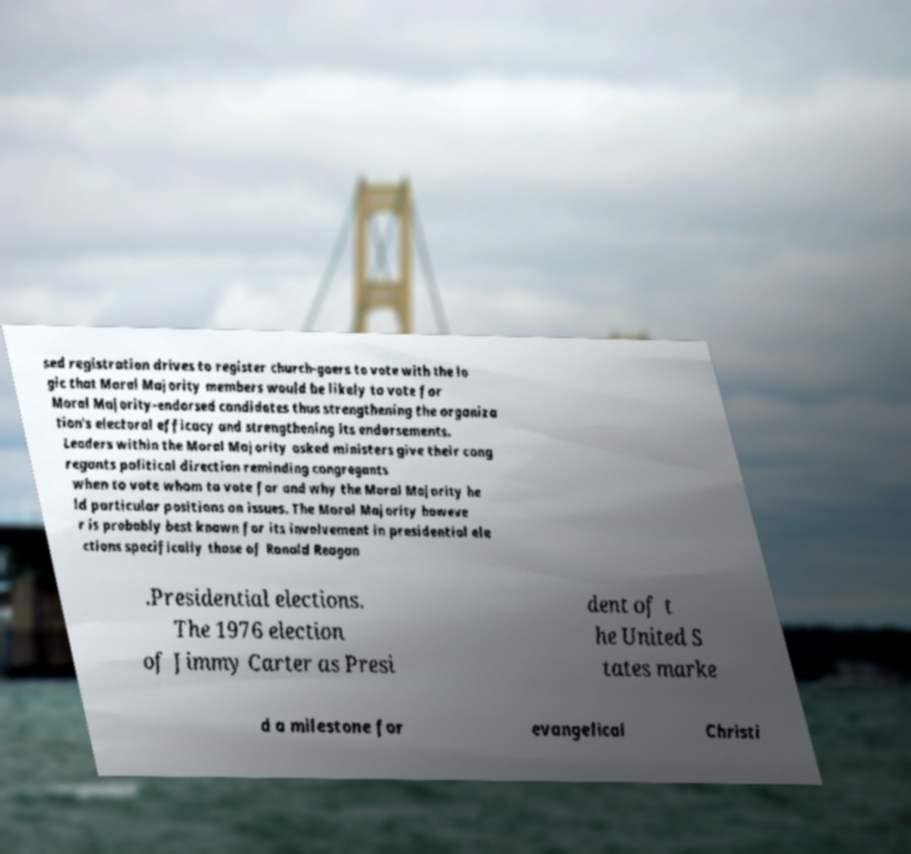Please identify and transcribe the text found in this image. sed registration drives to register church-goers to vote with the lo gic that Moral Majority members would be likely to vote for Moral Majority-endorsed candidates thus strengthening the organiza tion's electoral efficacy and strengthening its endorsements. Leaders within the Moral Majority asked ministers give their cong regants political direction reminding congregants when to vote whom to vote for and why the Moral Majority he ld particular positions on issues. The Moral Majority howeve r is probably best known for its involvement in presidential ele ctions specifically those of Ronald Reagan .Presidential elections. The 1976 election of Jimmy Carter as Presi dent of t he United S tates marke d a milestone for evangelical Christi 